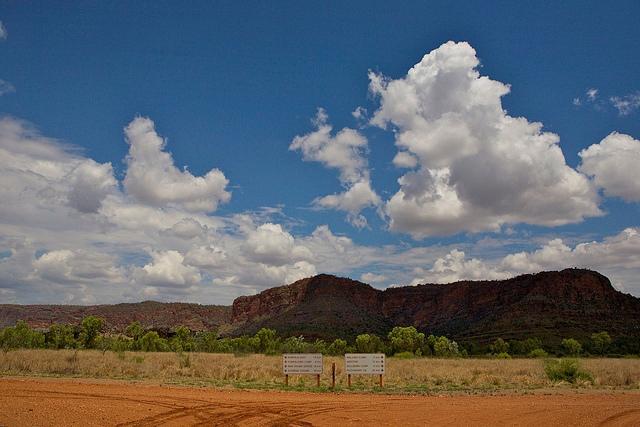Are there any clouds in the sky?
Give a very brief answer. Yes. Do you see a rainbow?
Short answer required. No. Is this a paved road?
Concise answer only. No. How many signs are on the edge of the field?
Quick response, please. 2. Is this a desert?
Be succinct. No. 